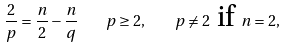Convert formula to latex. <formula><loc_0><loc_0><loc_500><loc_500>\frac { 2 } { p } = \frac { n } { 2 } - \frac { n } { q } \quad p \geq 2 , \quad p \neq 2 \ \text {if } n = 2 ,</formula> 